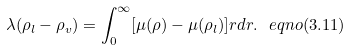<formula> <loc_0><loc_0><loc_500><loc_500>\lambda ( \rho _ { l } - \rho _ { v } ) = \int _ { 0 } ^ { \infty } [ \mu ( \rho ) - \mu ( \rho _ { l } ) ] r d r . \ e q n o ( 3 . 1 1 )</formula> 